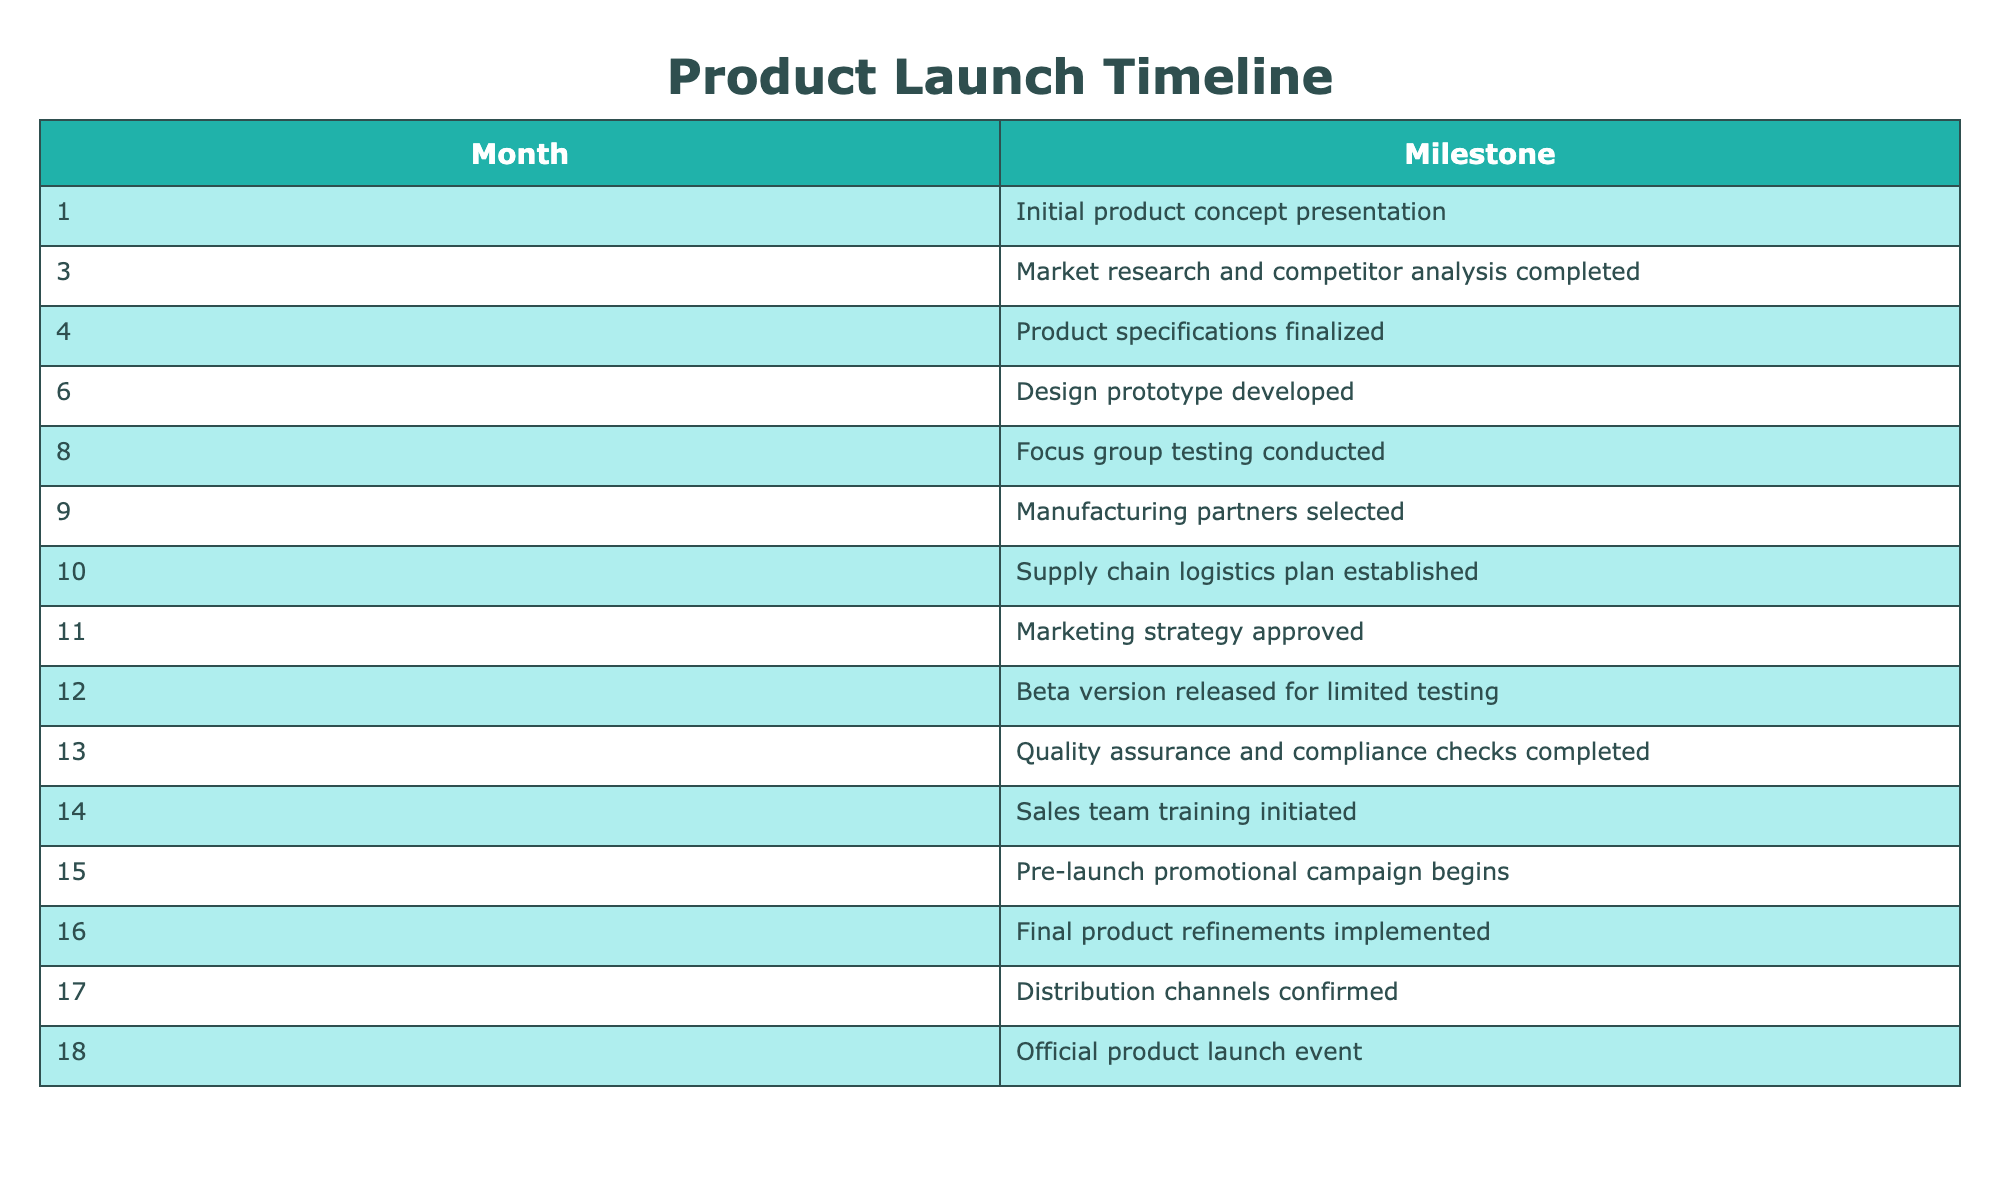What milestone occurs in month 3? According to the table, the milestone scheduled for month 3 is "Market research and competitor analysis completed."
Answer: Market research and competitor analysis completed What is the last milestone before the official product launch? The official product launch event occurs in month 18, and the last milestone before that, in month 17, is "Distribution channels confirmed."
Answer: Distribution channels confirmed How many months are there between the product specifications finalization and the beta version release? The product specifications are finalized in month 4, and the beta version is released in month 12. The difference is 12 - 4 = 8 months.
Answer: 8 months Is the marketing strategy approved before the supply chain logistics plan is established? The marketing strategy is approved in month 11, while the supply chain logistics plan is established in month 10. Therefore, the marketing strategy is approved after the logistics plan.
Answer: No Which month has the highest number of milestones? The table lists milestones in each month, but no month has more than one milestone. To determine the month with the highest milestone, you could inspect each month. Since all months have one milestone, there is no highest.
Answer: None How many months are planned for testing (including focus group and beta testing)? Focus group testing is conducted in month 8, and the beta version is released for limited testing in month 12. The months being counted are 8, 12; thus, there are two months planned for testing.
Answer: 2 months What is the cumulative total of months between the initial concept presentation and the final product refinements? The initial product concept presentation is in month 1 and the final product refinements are in month 16. The number of months between these two milestones is 16 - 1 = 15 months.
Answer: 15 months Was quality assurance conducted before the sales team training? Quality assurance and compliance checks are completed in month 13, while sales team training is initiated in month 14. Thus, quality assurance was completed before the sales training began.
Answer: Yes How many months are allocated for promotional activities leading up to the launch? The pre-launch promotional campaign begins in month 15, and the product launch occurs in month 18. This indicates that there are 3 months allocated for promotional activities before the launch.
Answer: 3 months 